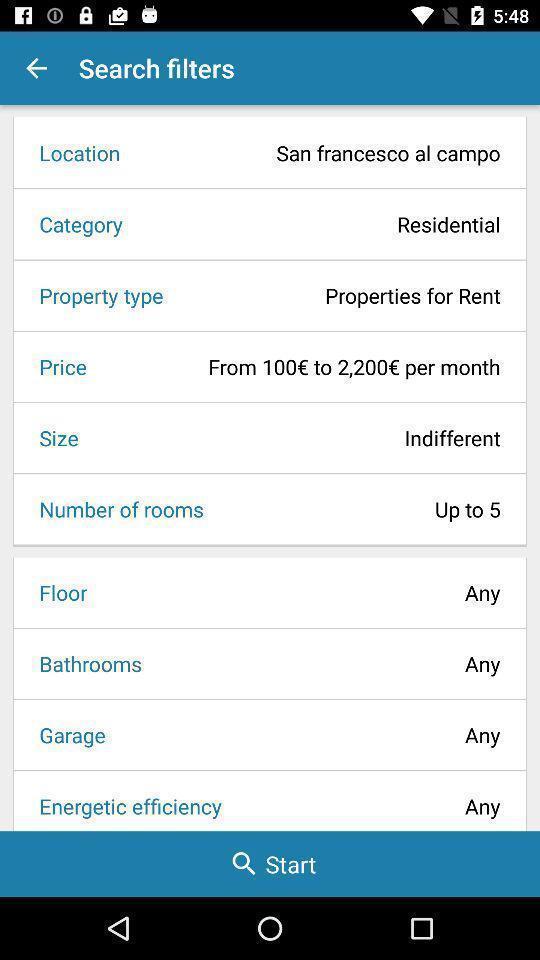Tell me what you see in this picture. Screen showing the search filters. 